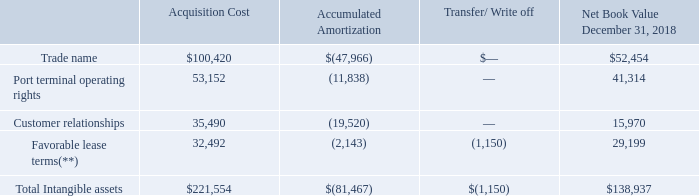NAVIOS MARITIME HOLDINGS INC. NOTES TO THE CONSOLIDATED FINANCIAL STATEMENTS (Expressed in thousands of U.S. dollars — except share data)
NOTE 8: INTANGIBLE ASSETS/LIABILITIES OTHER THAN GOODWILL
Net Book Value of Intangible Assets other than Goodwill as at December 31, 2018
(**) During the year ended December 31, 2018, acquisition costs of $1,150 of favorable lease terms were capitalized as part of the cost of one vessel due to the exercise of the purchase option (See also Note 2(n)). As of December 31, 2018, intangible assets associated with the favorable lease terms included an amount of $31,342 associated with the favorable lease terms of certain charter out contracts of Navios Containers which were recognized as of November 30, 2018 (see Note 3). During the year ended December 31, 2017, acquisition costs of $10,398 and accumulated amortization of $7,001 of favorable lease terms were considered impaired and were written off resulting in a loss of $3,397 included in the statement of comprehensive (loss)/income within the caption of “Impairment loss/ loss on sale of vessels, net”.
What was the net book value of trade name?
Answer scale should be: thousand. 52,454. What was the acquisition cost of Port terminal operating rights?
Answer scale should be: thousand. 53,152. What was the Accumulated Amortization of favorable lease terms?
Answer scale should be: thousand. (2,143). How many intangible assets had an acquisition cost that exceeded $50,000 thousand? Trade name##Port terminal operating rights
Answer: 2. What was the difference in the net book value between trade name and port terminal operating rights?
Answer scale should be: thousand. 52,454-41,314
Answer: 11140. What was the difference between the accumulated amortization between Customer relationships and favorable lease terms?
Answer scale should be: thousand. -19,520-(-2,143)
Answer: -17377. 